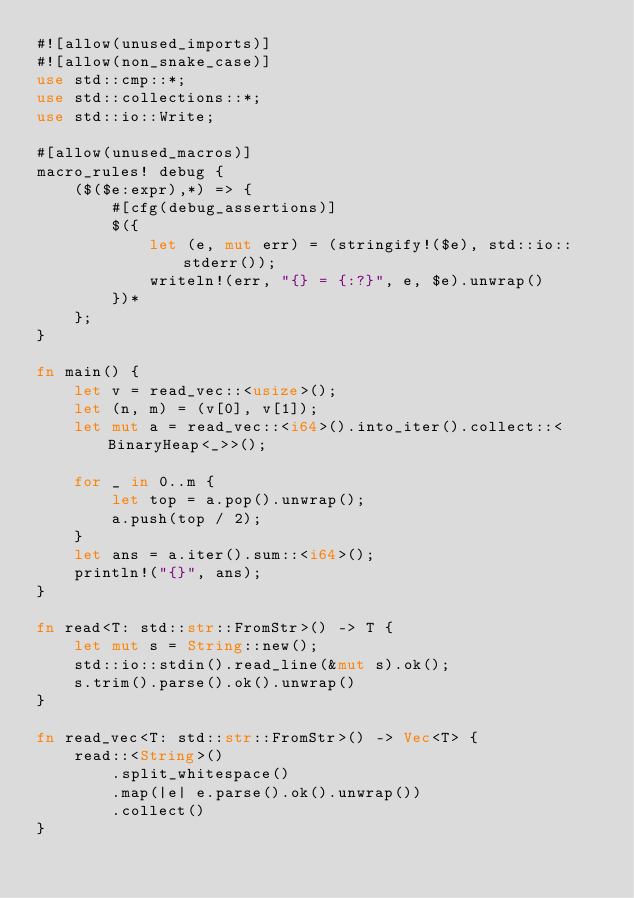Convert code to text. <code><loc_0><loc_0><loc_500><loc_500><_Rust_>#![allow(unused_imports)]
#![allow(non_snake_case)]
use std::cmp::*;
use std::collections::*;
use std::io::Write;

#[allow(unused_macros)]
macro_rules! debug {
    ($($e:expr),*) => {
        #[cfg(debug_assertions)]
        $({
            let (e, mut err) = (stringify!($e), std::io::stderr());
            writeln!(err, "{} = {:?}", e, $e).unwrap()
        })*
    };
}

fn main() {
    let v = read_vec::<usize>();
    let (n, m) = (v[0], v[1]);
    let mut a = read_vec::<i64>().into_iter().collect::<BinaryHeap<_>>();

    for _ in 0..m {
        let top = a.pop().unwrap();
        a.push(top / 2);
    }
    let ans = a.iter().sum::<i64>();
    println!("{}", ans);
}

fn read<T: std::str::FromStr>() -> T {
    let mut s = String::new();
    std::io::stdin().read_line(&mut s).ok();
    s.trim().parse().ok().unwrap()
}

fn read_vec<T: std::str::FromStr>() -> Vec<T> {
    read::<String>()
        .split_whitespace()
        .map(|e| e.parse().ok().unwrap())
        .collect()
}
</code> 